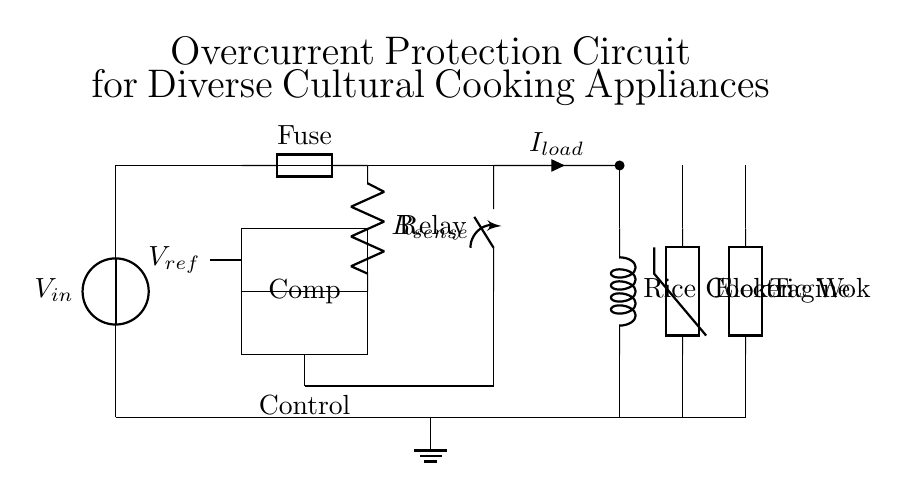What is the input voltage in this circuit? The input voltage is indicated by the voltage source labeled as V_in at the left of the circuit diagram.
Answer: V_in What is the function of the fuse in this circuit? The fuse is included to protect the circuit from overcurrent conditions by breaking the circuit when the current exceeds a specific threshold.
Answer: Overcurrent protection What type of appliances are connected in this circuit? The circuit has three types of cooking appliances connected: a rice cooker, an electric wok, and a tagine. Their respective symbols can be identified near the right side of the diagram.
Answer: Rice cooker, electric wok, tagine What is the role of the resistor labeled R_sense? R_sense is used to measure current flowing through the circuit by developing a small voltage proportional to the current, which is then used for monitoring or control.
Answer: Current sensing What triggers the control circuit to cut off power? The control circuit is triggered to cut off power when the comparator detects a voltage across the sense resistor that exceeds the reference voltage V_ref, indicating an overcurrent condition.
Answer: Comparator and reference voltage Which component is responsible for the disconnection of the load in case of an overcurrent? The relay is the component that physically disconnects the load when a control signal is received from the control circuit, ensuring safety during overcurrent situations.
Answer: Relay 